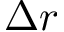<formula> <loc_0><loc_0><loc_500><loc_500>\Delta r</formula> 